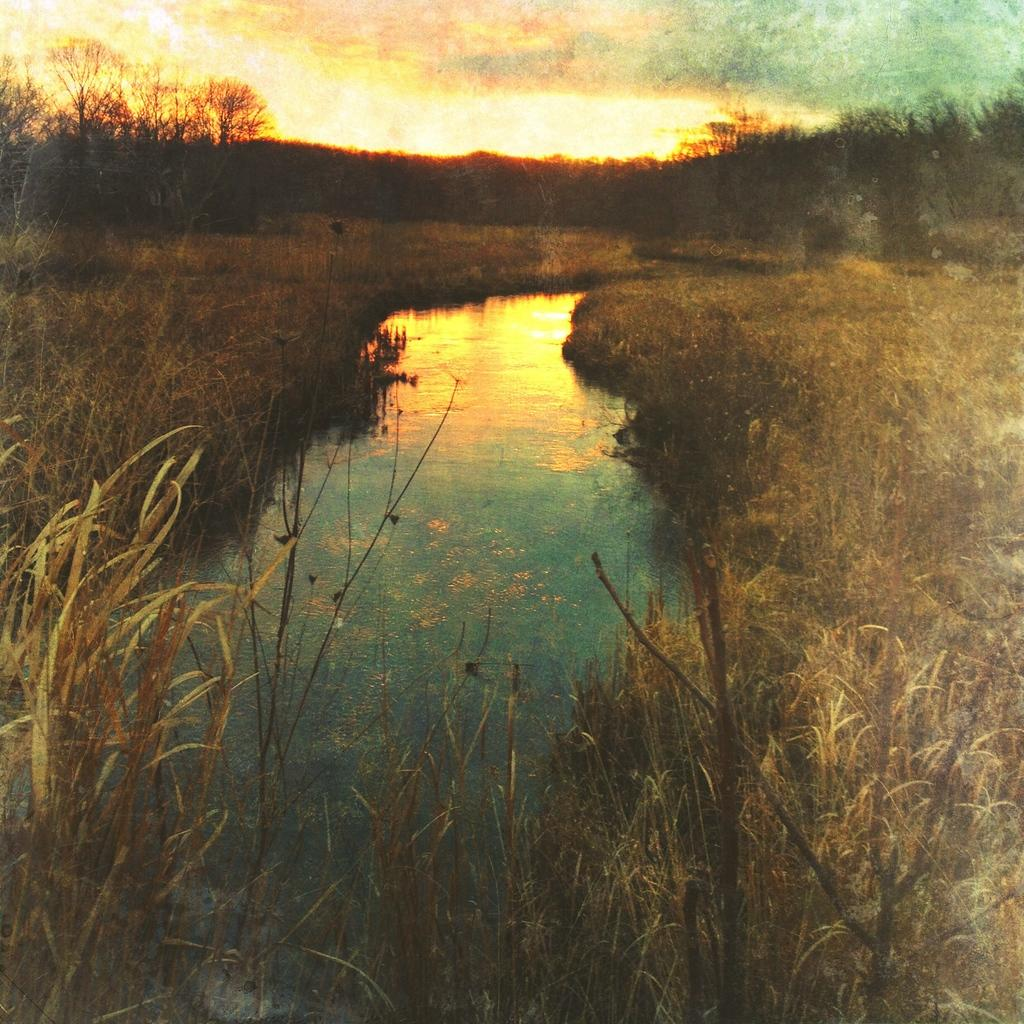What type of ground surface is at the bottom of the image? There is grass at the bottom of the image. What natural element is visible in the image? There is water visible in the image. What type of vegetation can be seen in the background of the image? There are trees in the background of the image. What is visible at the top of the image? The sky is visible at the top of the image. Can you tell me how many worms are crawling in the eggnog in the image? There is no eggnog or worms present in the image. What type of payment is being made in the image? There is no payment being made in the image; it features grass, water, trees, and the sky. 